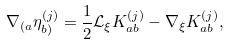Convert formula to latex. <formula><loc_0><loc_0><loc_500><loc_500>\nabla _ { ( a } \eta ^ { ( j ) } _ { b ) } = \frac { 1 } { 2 } \mathcal { L } _ { \xi } K ^ { ( j ) } _ { a b } - \nabla _ { \xi } K ^ { ( j ) } _ { a b } ,</formula> 